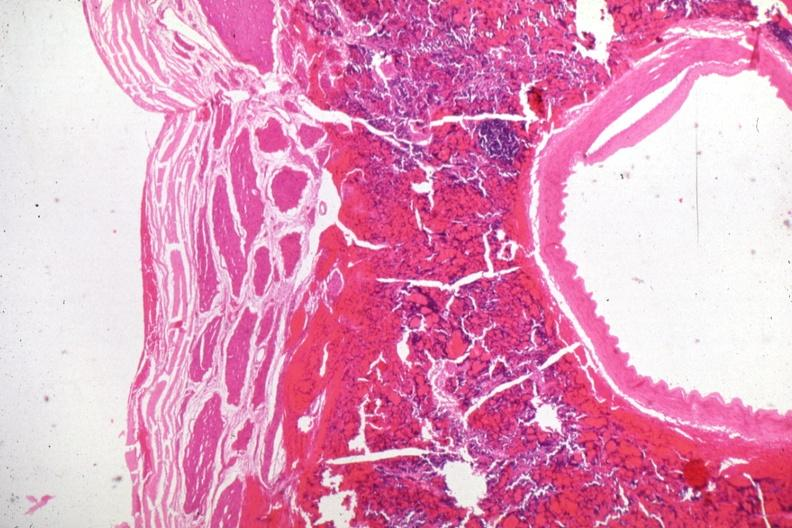s aorta present?
Answer the question using a single word or phrase. No 